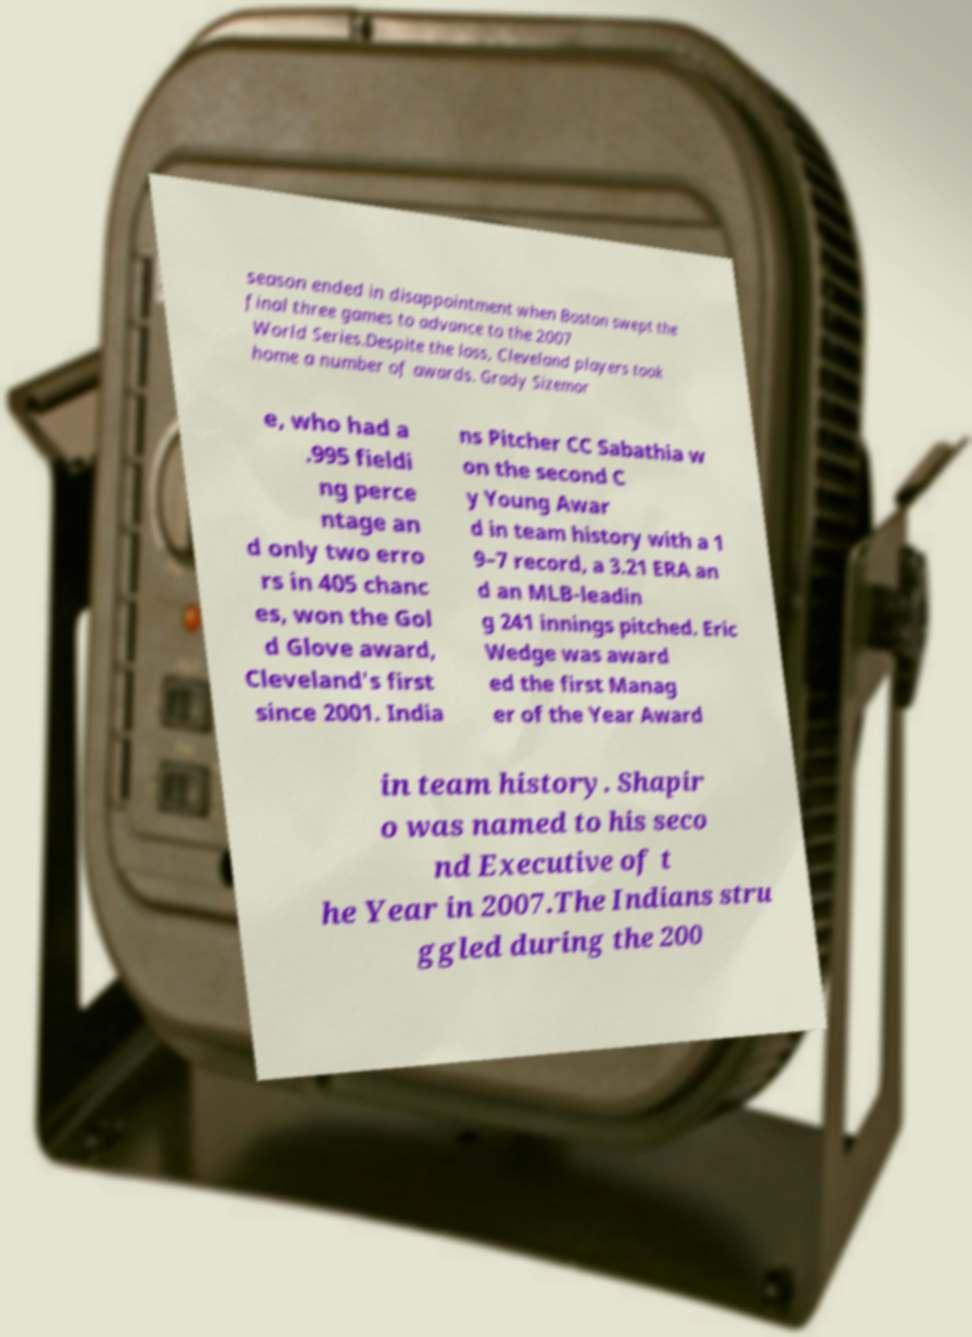Please read and relay the text visible in this image. What does it say? season ended in disappointment when Boston swept the final three games to advance to the 2007 World Series.Despite the loss, Cleveland players took home a number of awards. Grady Sizemor e, who had a .995 fieldi ng perce ntage an d only two erro rs in 405 chanc es, won the Gol d Glove award, Cleveland's first since 2001. India ns Pitcher CC Sabathia w on the second C y Young Awar d in team history with a 1 9–7 record, a 3.21 ERA an d an MLB-leadin g 241 innings pitched. Eric Wedge was award ed the first Manag er of the Year Award in team history. Shapir o was named to his seco nd Executive of t he Year in 2007.The Indians stru ggled during the 200 